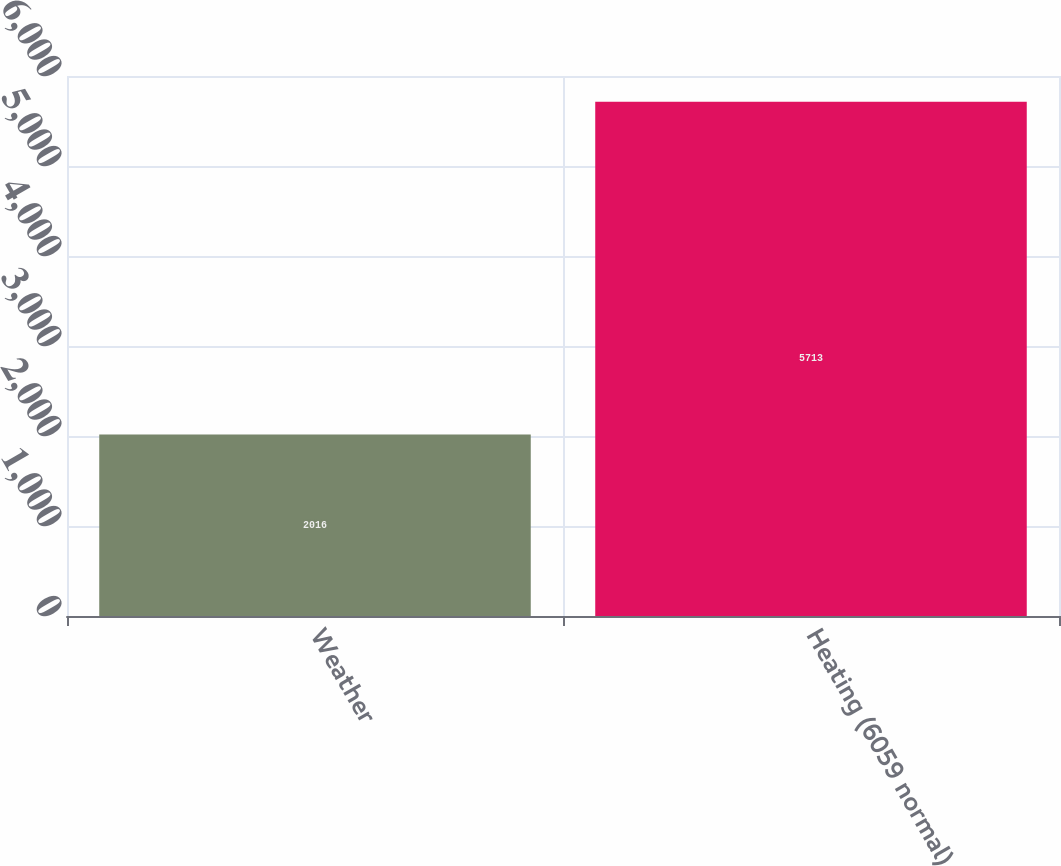Convert chart to OTSL. <chart><loc_0><loc_0><loc_500><loc_500><bar_chart><fcel>Weather<fcel>Heating (6059 normal)<nl><fcel>2016<fcel>5713<nl></chart> 